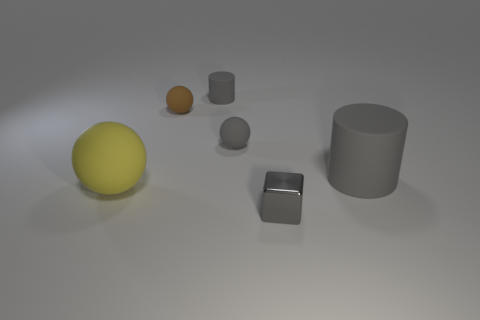Add 4 tiny gray metallic spheres. How many objects exist? 10 Subtract all cylinders. How many objects are left? 4 Add 4 small gray cubes. How many small gray cubes exist? 5 Subtract 0 green balls. How many objects are left? 6 Subtract all purple metal cylinders. Subtract all cylinders. How many objects are left? 4 Add 4 tiny brown matte objects. How many tiny brown matte objects are left? 5 